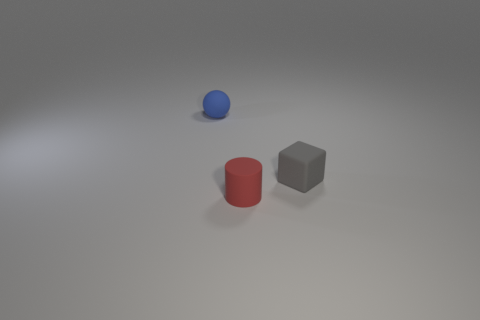Add 3 gray matte things. How many objects exist? 6 Subtract 1 cubes. How many cubes are left? 0 Subtract all small gray blocks. Subtract all tiny gray cubes. How many objects are left? 1 Add 3 gray things. How many gray things are left? 4 Add 1 small gray matte blocks. How many small gray matte blocks exist? 2 Subtract 0 purple cylinders. How many objects are left? 3 Subtract all cubes. How many objects are left? 2 Subtract all purple balls. Subtract all red cylinders. How many balls are left? 1 